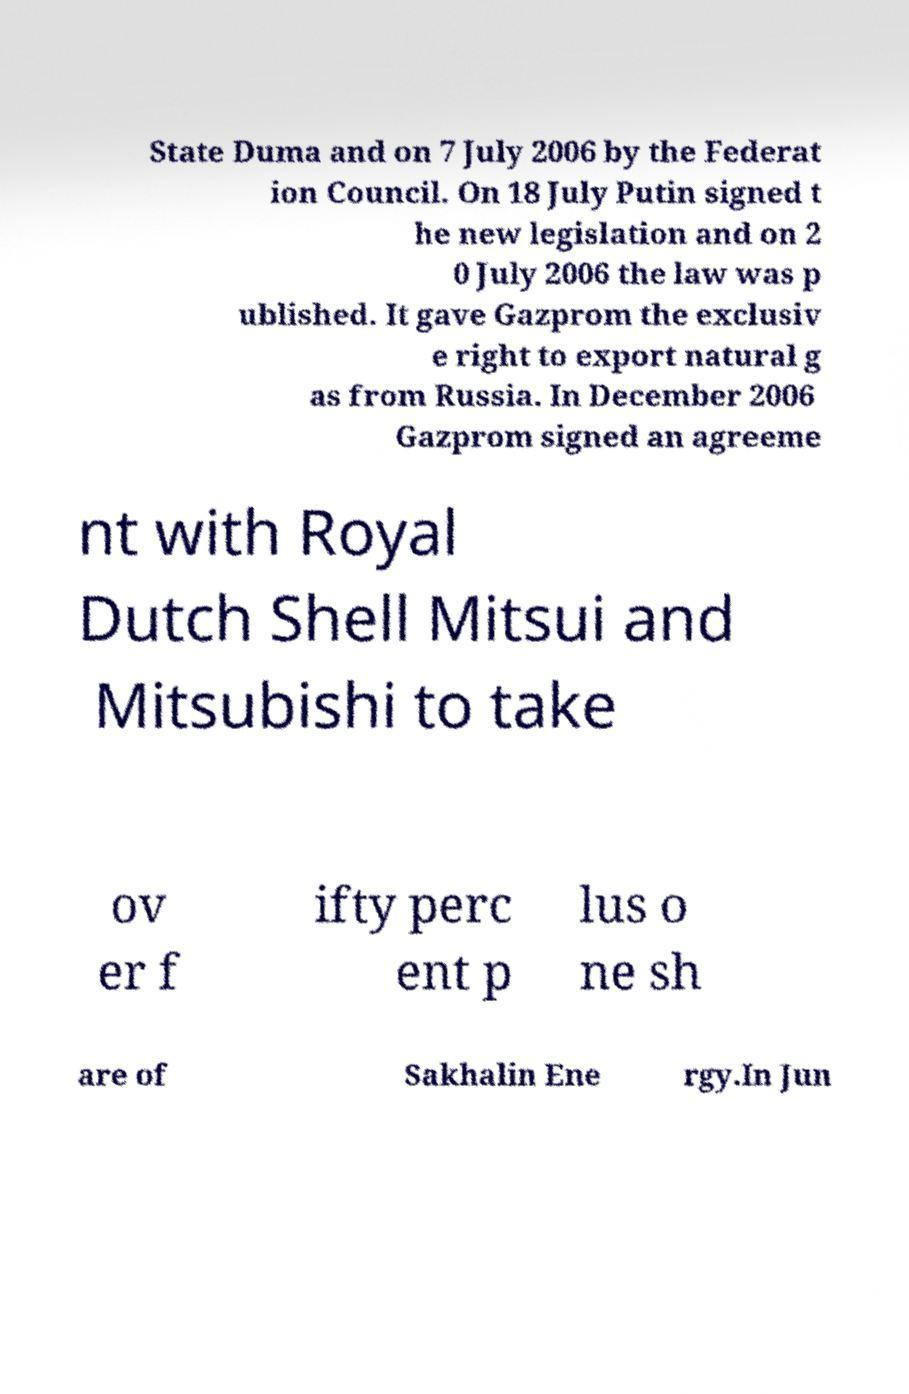For documentation purposes, I need the text within this image transcribed. Could you provide that? State Duma and on 7 July 2006 by the Federat ion Council. On 18 July Putin signed t he new legislation and on 2 0 July 2006 the law was p ublished. It gave Gazprom the exclusiv e right to export natural g as from Russia. In December 2006 Gazprom signed an agreeme nt with Royal Dutch Shell Mitsui and Mitsubishi to take ov er f ifty perc ent p lus o ne sh are of Sakhalin Ene rgy.In Jun 